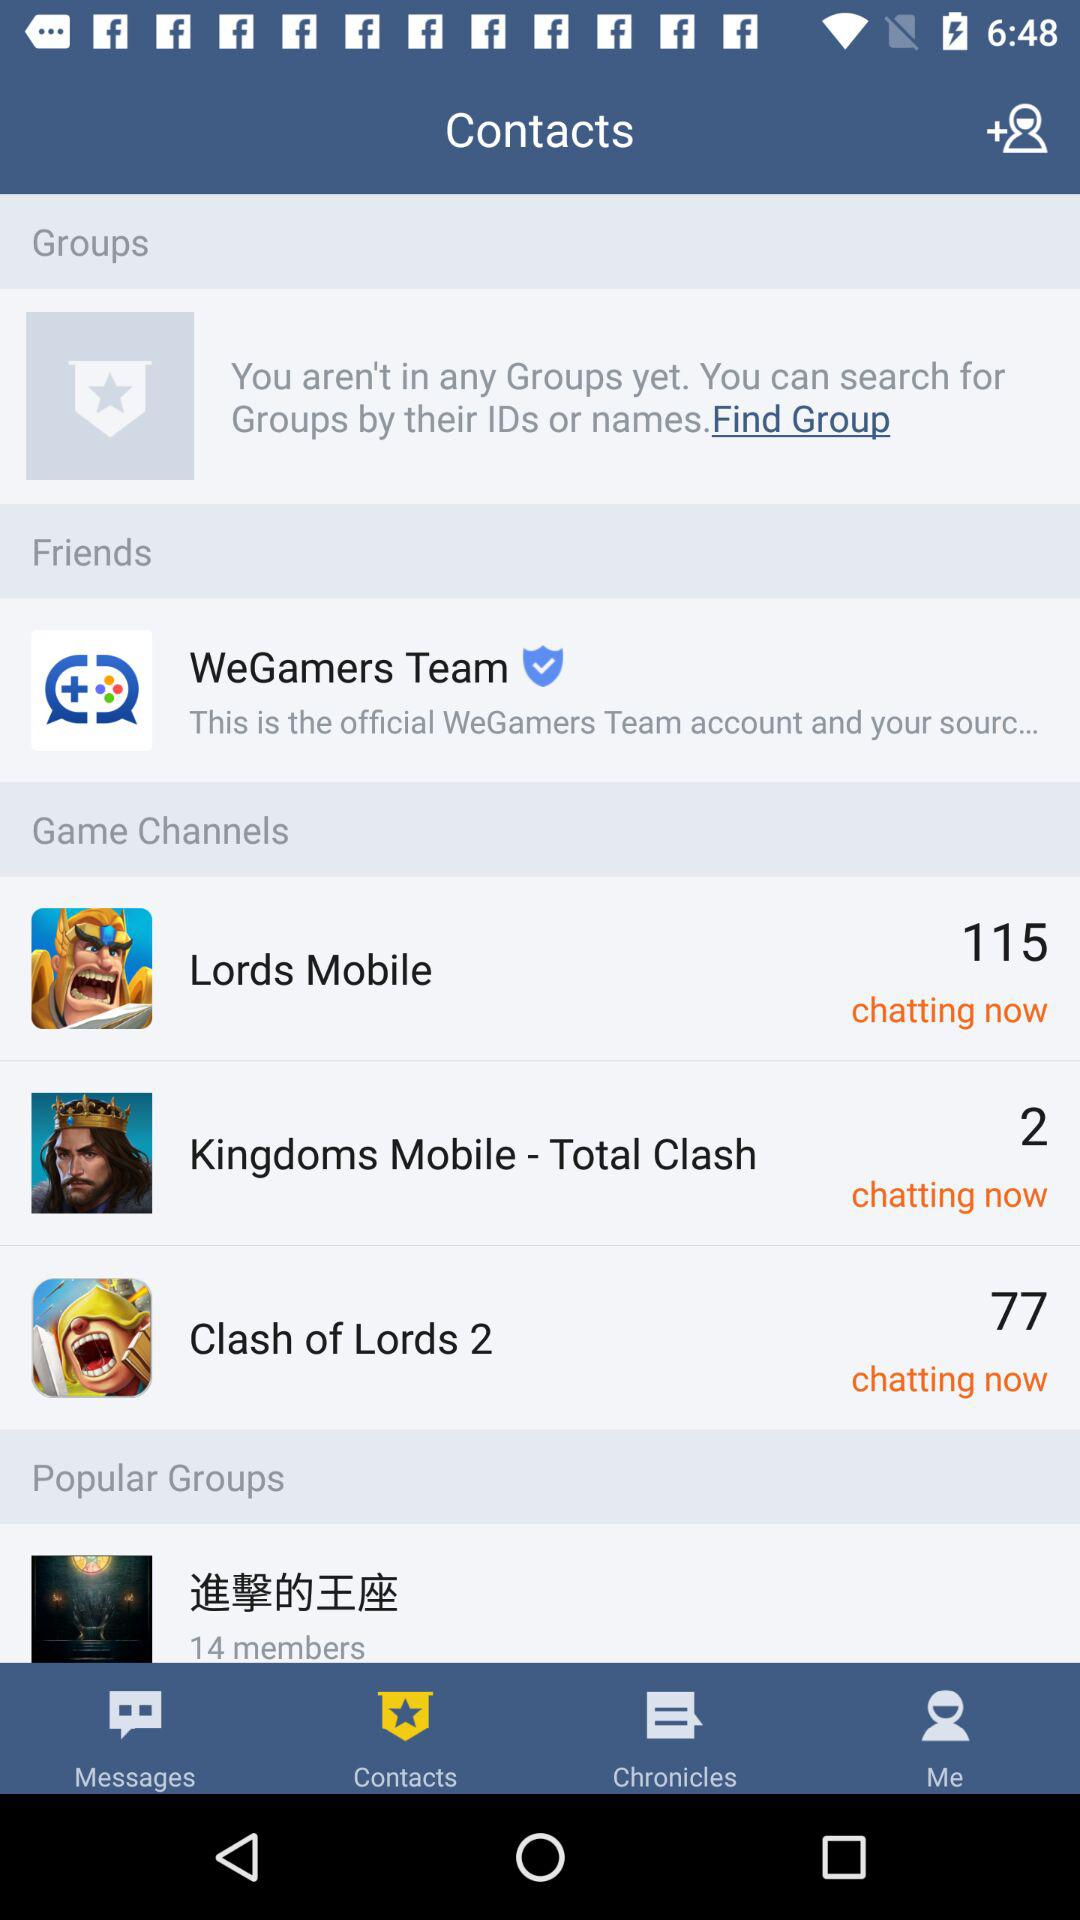How many people are chatting in the "Lords Mobile" game? There are 115 people who are chatting in the "Lords Mobile" game. 